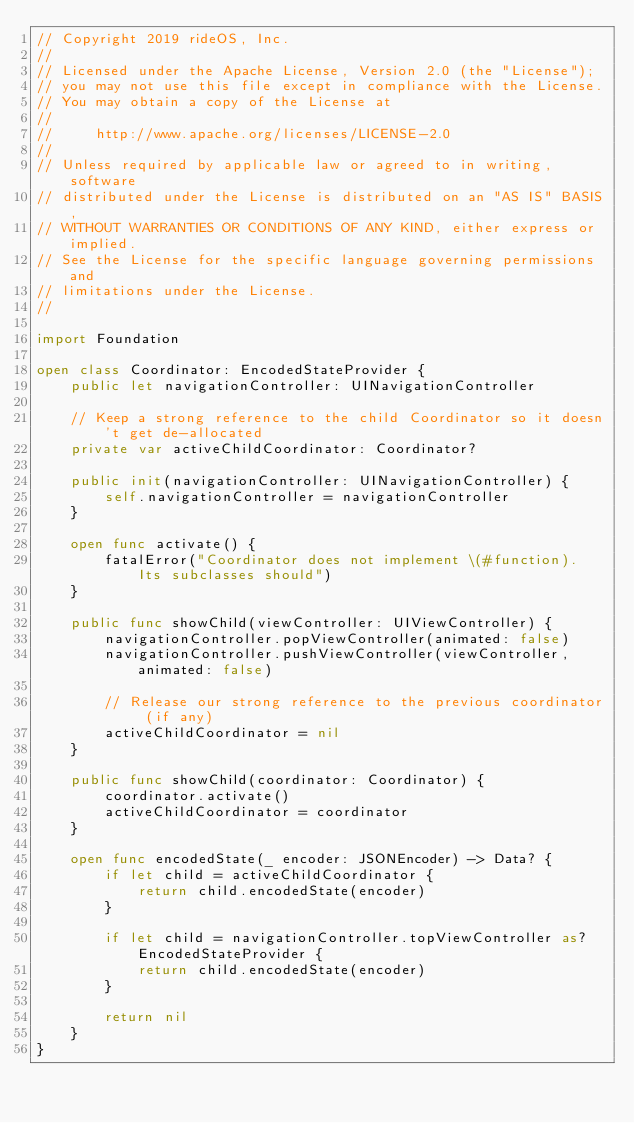Convert code to text. <code><loc_0><loc_0><loc_500><loc_500><_Swift_>// Copyright 2019 rideOS, Inc.
//
// Licensed under the Apache License, Version 2.0 (the "License");
// you may not use this file except in compliance with the License.
// You may obtain a copy of the License at
//
//     http://www.apache.org/licenses/LICENSE-2.0
//
// Unless required by applicable law or agreed to in writing, software
// distributed under the License is distributed on an "AS IS" BASIS,
// WITHOUT WARRANTIES OR CONDITIONS OF ANY KIND, either express or implied.
// See the License for the specific language governing permissions and
// limitations under the License.
//

import Foundation

open class Coordinator: EncodedStateProvider {
    public let navigationController: UINavigationController

    // Keep a strong reference to the child Coordinator so it doesn't get de-allocated
    private var activeChildCoordinator: Coordinator?

    public init(navigationController: UINavigationController) {
        self.navigationController = navigationController
    }

    open func activate() {
        fatalError("Coordinator does not implement \(#function). Its subclasses should")
    }

    public func showChild(viewController: UIViewController) {
        navigationController.popViewController(animated: false)
        navigationController.pushViewController(viewController, animated: false)

        // Release our strong reference to the previous coordinator (if any)
        activeChildCoordinator = nil
    }

    public func showChild(coordinator: Coordinator) {
        coordinator.activate()
        activeChildCoordinator = coordinator
    }

    open func encodedState(_ encoder: JSONEncoder) -> Data? {
        if let child = activeChildCoordinator {
            return child.encodedState(encoder)
        }

        if let child = navigationController.topViewController as? EncodedStateProvider {
            return child.encodedState(encoder)
        }

        return nil
    }
}
</code> 